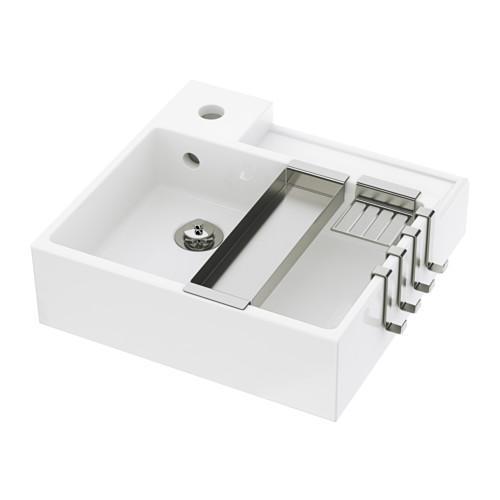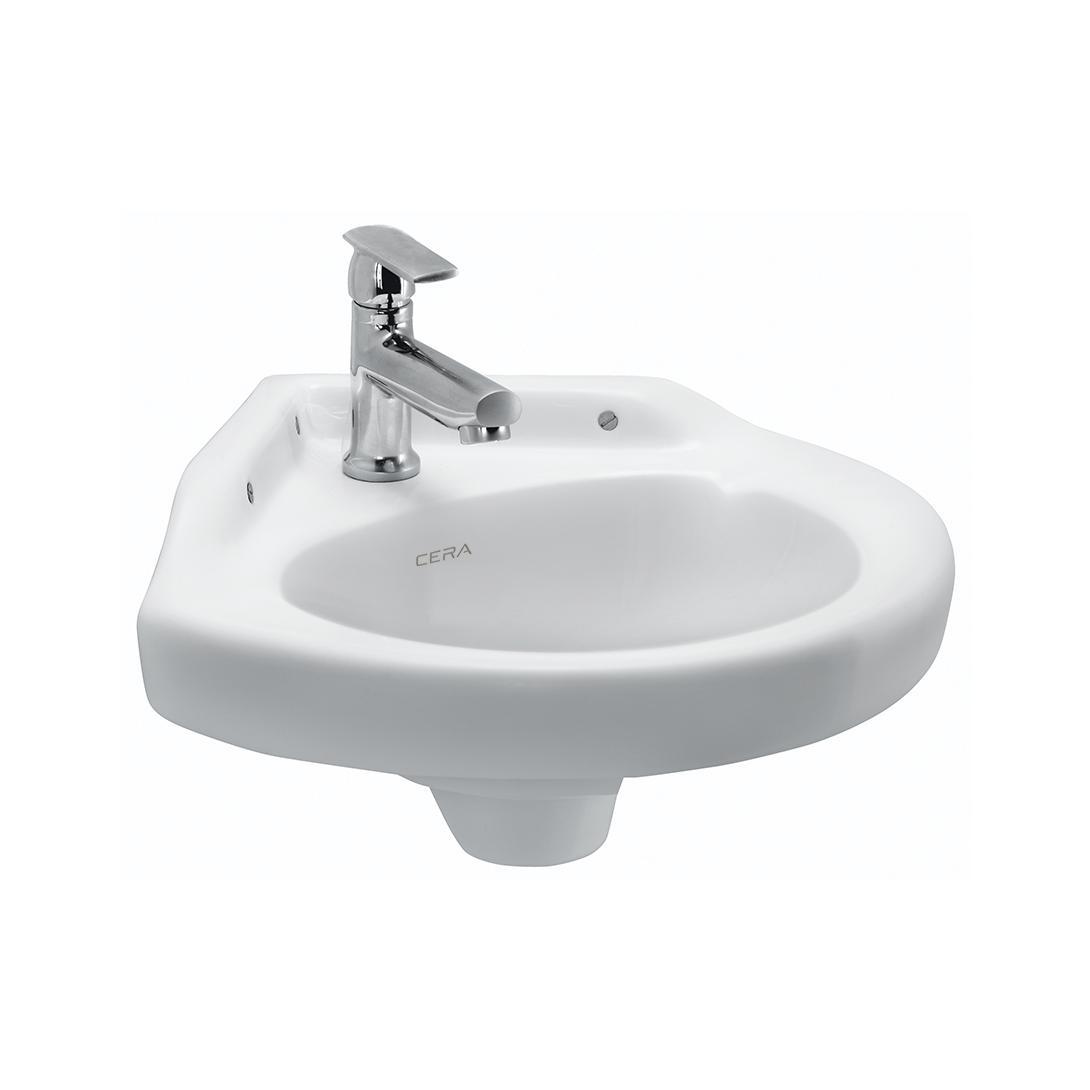The first image is the image on the left, the second image is the image on the right. Assess this claim about the two images: "Each sink has a rounded outer edge and back edge that fits parallel to a wall.". Correct or not? Answer yes or no. No. 